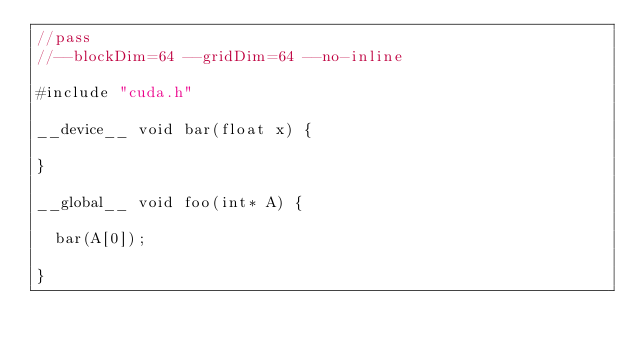<code> <loc_0><loc_0><loc_500><loc_500><_Cuda_>//pass
//--blockDim=64 --gridDim=64 --no-inline

#include "cuda.h"

__device__ void bar(float x) {

}

__global__ void foo(int* A) {

  bar(A[0]);

}
</code> 